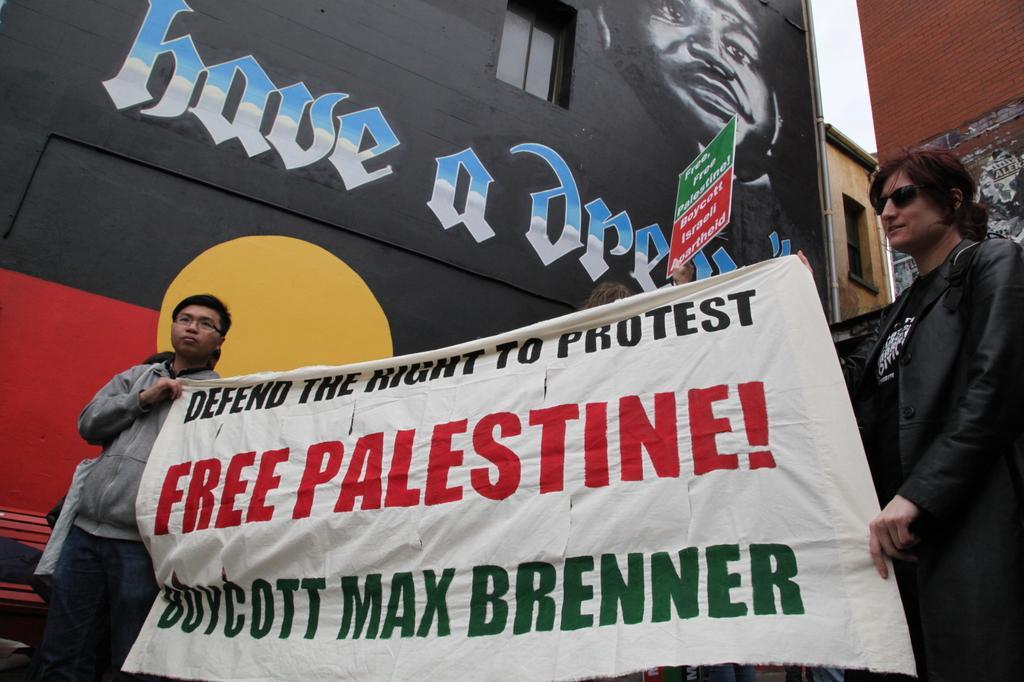Describe this image in one or two sentences. There are two persons holding a banner in their hands and there is a hoarding in a person hand. In the background there is a picture and a text written on the wall and we can see a pole,windows and the sky. 